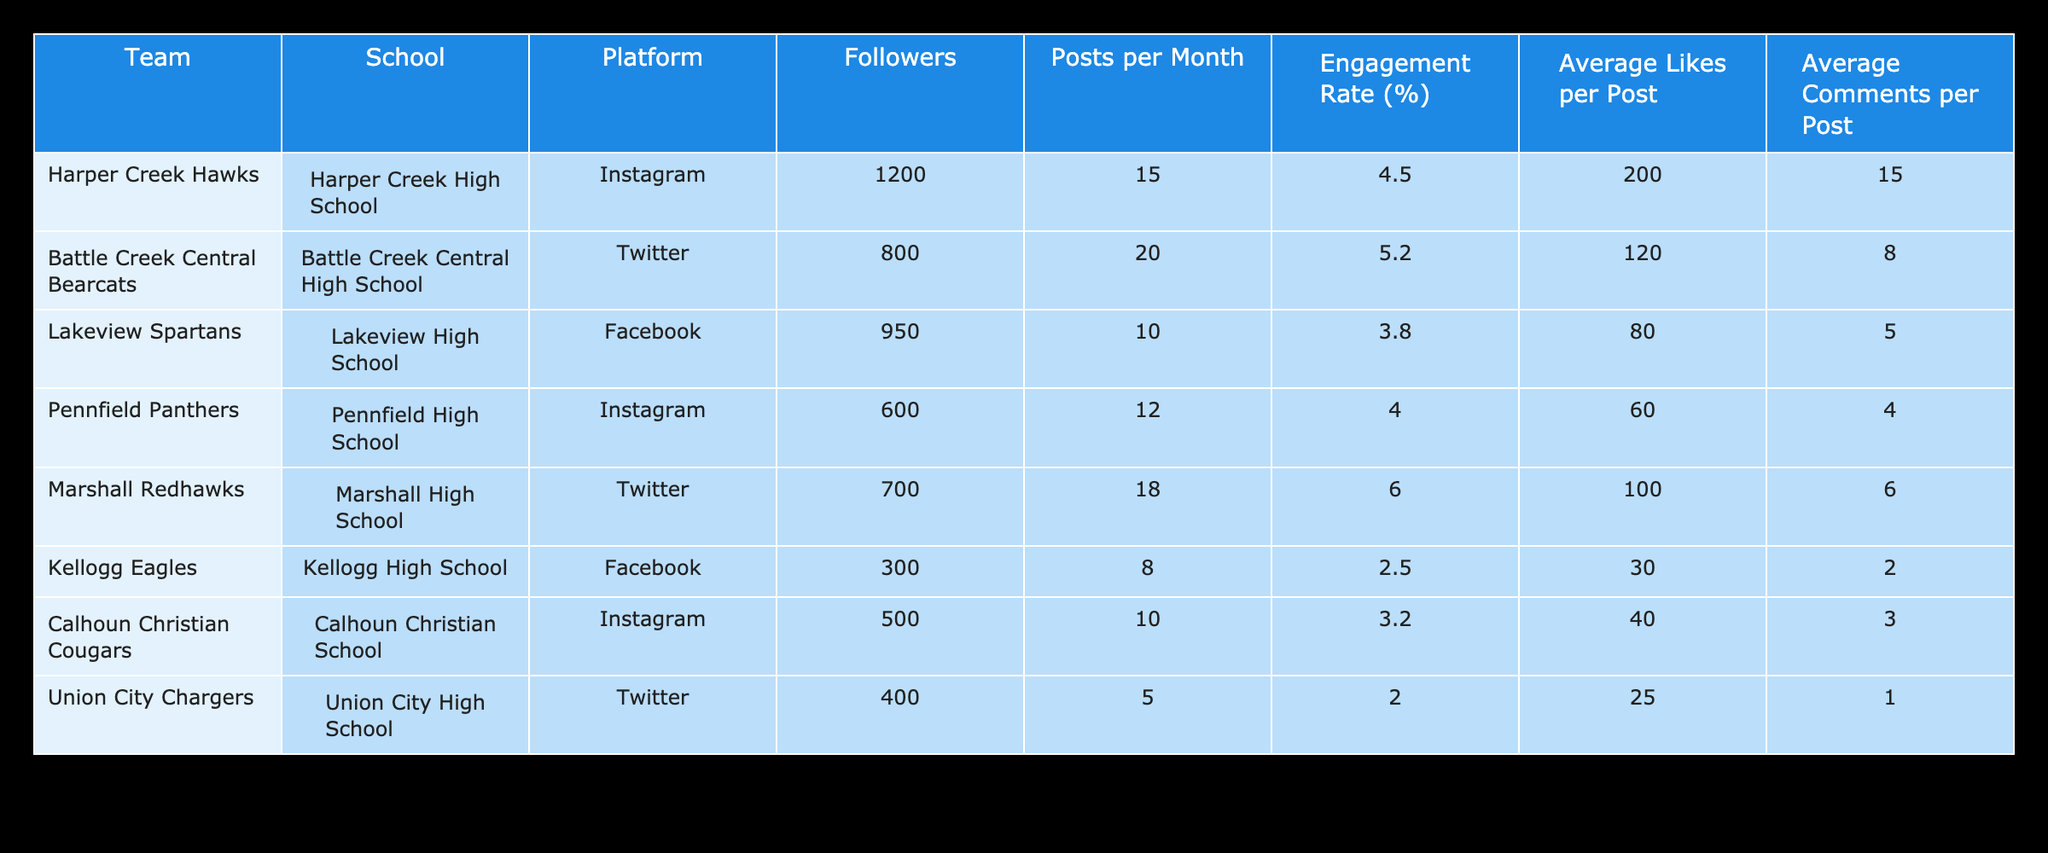What team has the highest engagement rate on social media? Looking at the Engagement Rate column, I can see that the Marshall Redhawks have an engagement rate of 6.0%, which is higher than any other team listed.
Answer: Marshall Redhawks How many followers does the Harper Creek Hawks have? The Followers column for Harper Creek Hawks shows a value of 1200, indicating the number of followers on their social media platform.
Answer: 1200 What is the average number of posts per month across all teams? To find the average, I will add the number of posts per month: (15 + 20 + 10 + 12 + 18 + 8 + 10 + 5) = 98. There are 8 teams, so the average is 98/8 = 12.25 posts per month.
Answer: 12.25 Is it true that the Union City Chargers have more followers than the Kellogg Eagles? In the Followers column, Union City Chargers have 400 followers while Kellogg Eagles have 300. Thus, it is not true that Union City Chargers have more followers than Kellogg Eagles.
Answer: No What is the total average likes per post from all teams? I need to sum the Average Likes per Post values: (200 + 120 + 80 + 60 + 100 + 30 + 40 + 25) = 655. Then, I divide by the number of teams: 655 / 8 = 81.875.
Answer: 81.875 Which school's team has the least number of posts per month? By checking the Posts per Month column, I see the Union City Chargers have the least posts at 5.
Answer: Union City Chargers What are the average comments per post for the Pennfield Panthers? From the table, the Average Comments per Post for Pennfield Panthers is 4, which is directly listed under their row.
Answer: 4 Which team has the lowest engagement rate and what is that rate? Looking through the Engagement Rate column, the Kellogg Eagles are the team with the lowest engagement rate at 2.5%.
Answer: Kellogg Eagles, 2.5% 